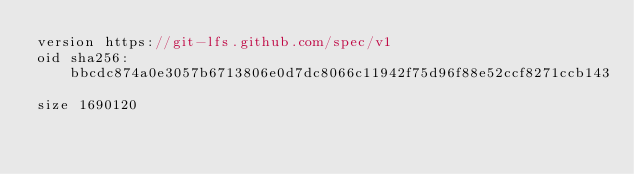<code> <loc_0><loc_0><loc_500><loc_500><_TypeScript_>version https://git-lfs.github.com/spec/v1
oid sha256:bbcdc874a0e3057b6713806e0d7dc8066c11942f75d96f88e52ccf8271ccb143
size 1690120
</code> 